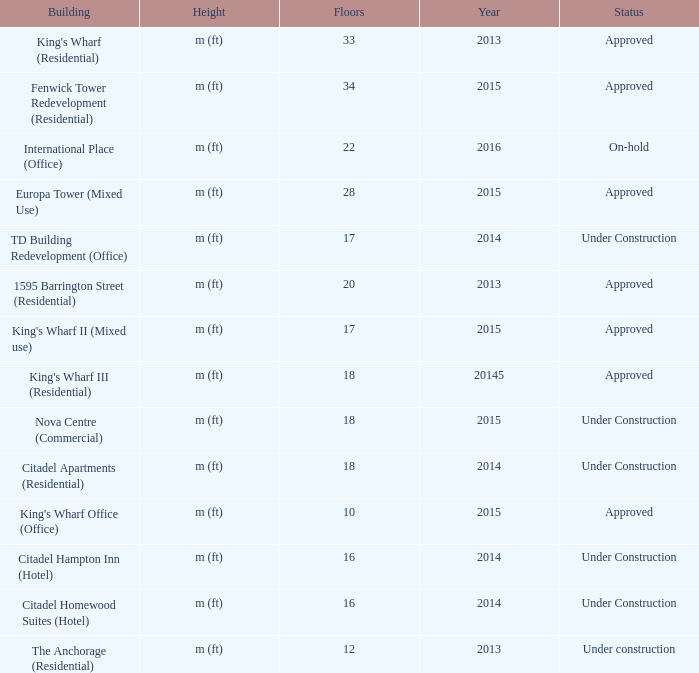What building shows 2013 and has more than 20 floors? King's Wharf (Residential). 